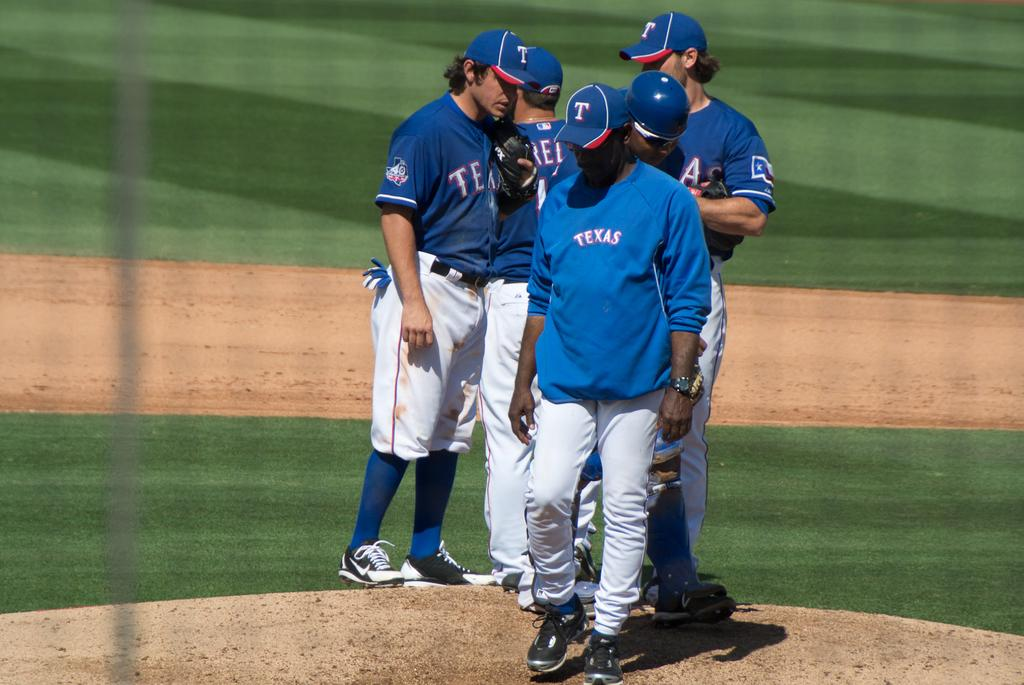Provide a one-sentence caption for the provided image. a man wearing a TEXAS jacket walks away from the players. 